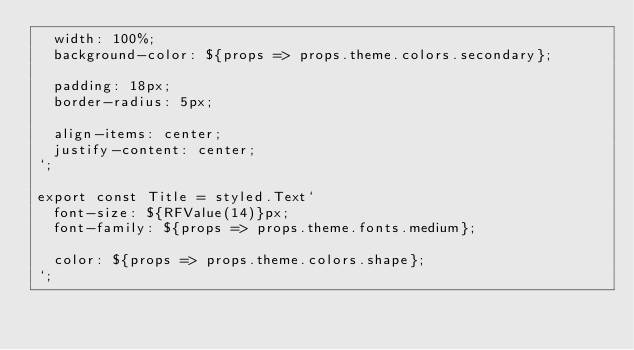Convert code to text. <code><loc_0><loc_0><loc_500><loc_500><_TypeScript_>  width: 100%;
  background-color: ${props => props.theme.colors.secondary};

  padding: 18px;
  border-radius: 5px;

  align-items: center;
  justify-content: center;
`;

export const Title = styled.Text`
  font-size: ${RFValue(14)}px;
  font-family: ${props => props.theme.fonts.medium};

  color: ${props => props.theme.colors.shape};
`;
</code> 